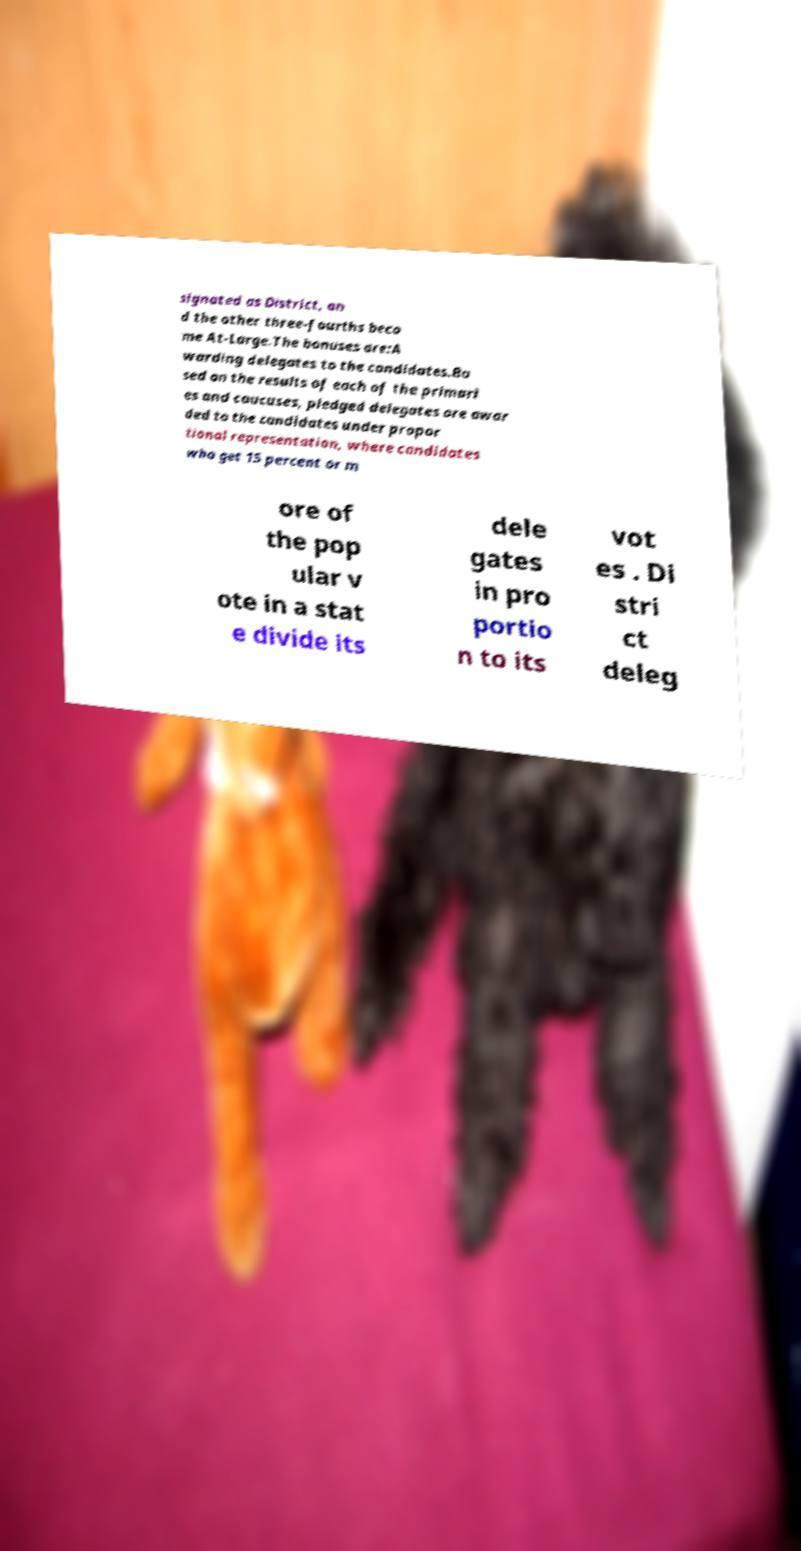What messages or text are displayed in this image? I need them in a readable, typed format. signated as District, an d the other three-fourths beco me At-Large.The bonuses are:A warding delegates to the candidates.Ba sed on the results of each of the primari es and caucuses, pledged delegates are awar ded to the candidates under propor tional representation, where candidates who get 15 percent or m ore of the pop ular v ote in a stat e divide its dele gates in pro portio n to its vot es . Di stri ct deleg 